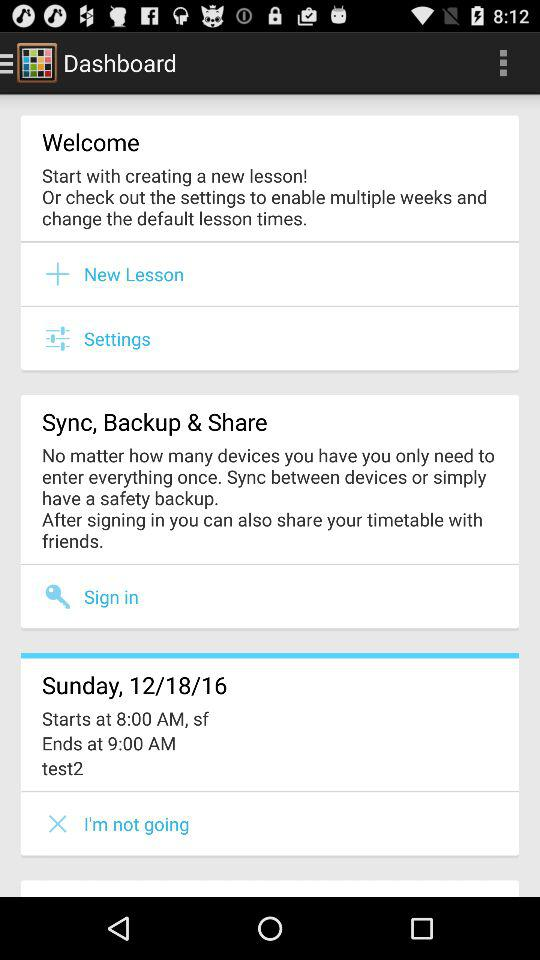What is the timing for "test2"? The timing is from 8:00 AM to 9:00 AM. 